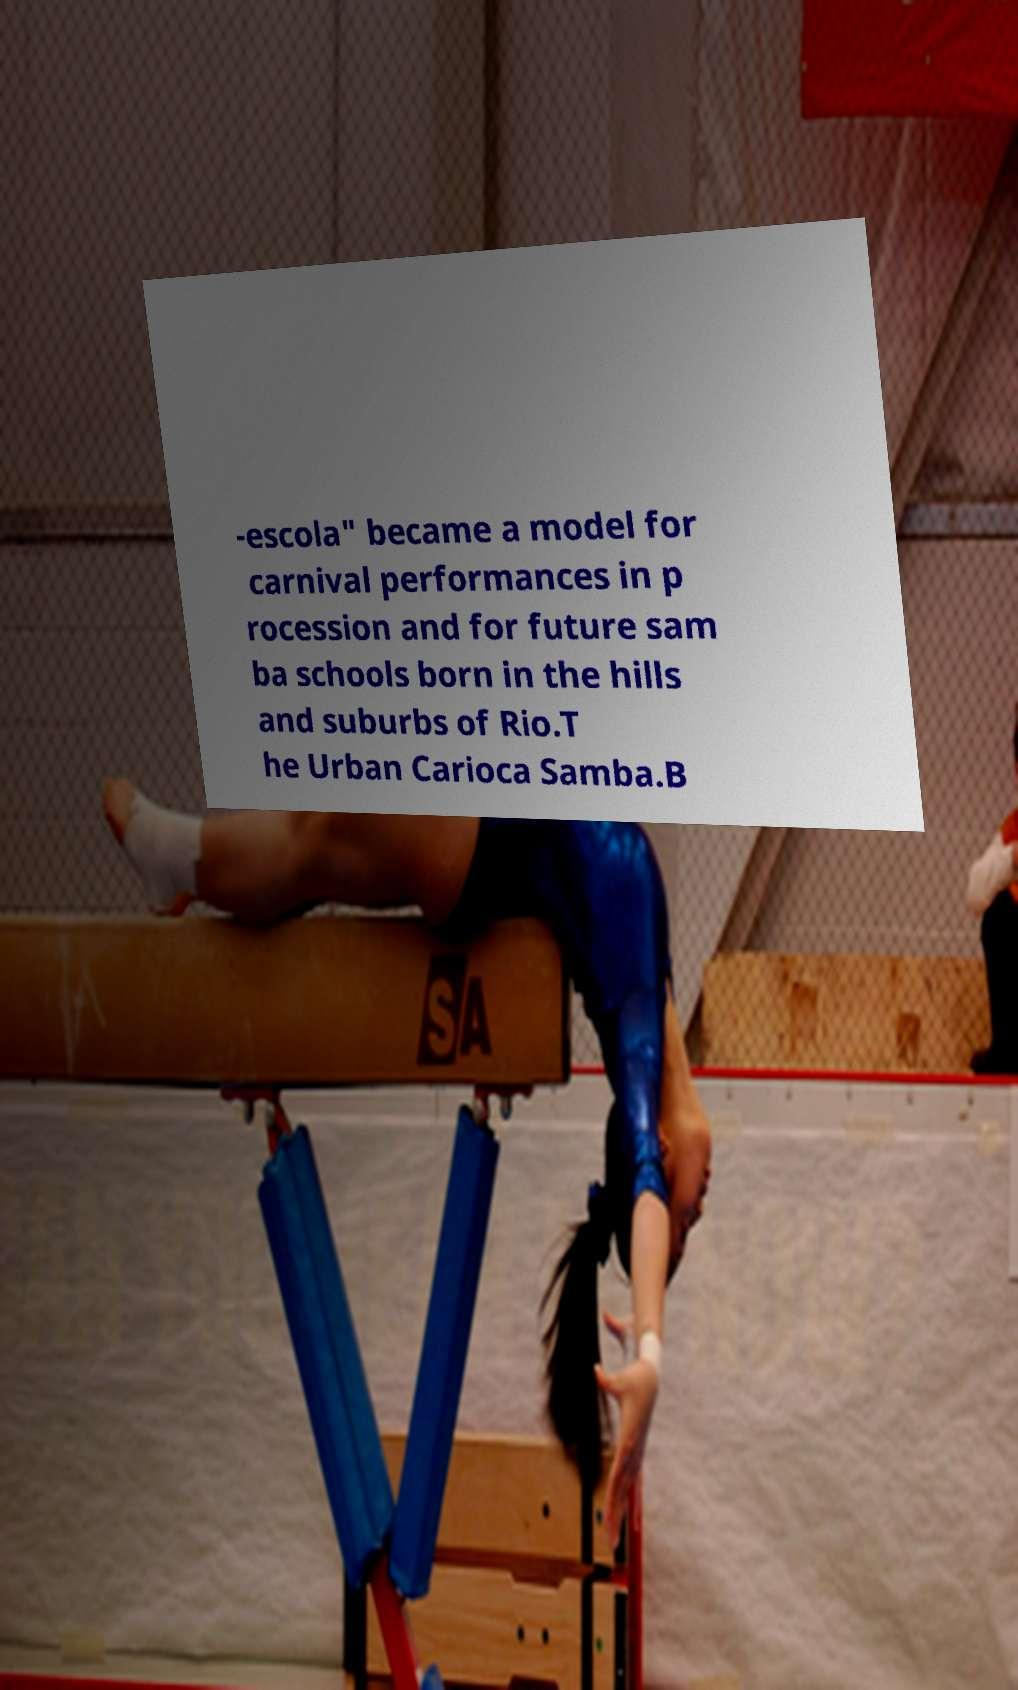For documentation purposes, I need the text within this image transcribed. Could you provide that? -escola" became a model for carnival performances in p rocession and for future sam ba schools born in the hills and suburbs of Rio.T he Urban Carioca Samba.B 